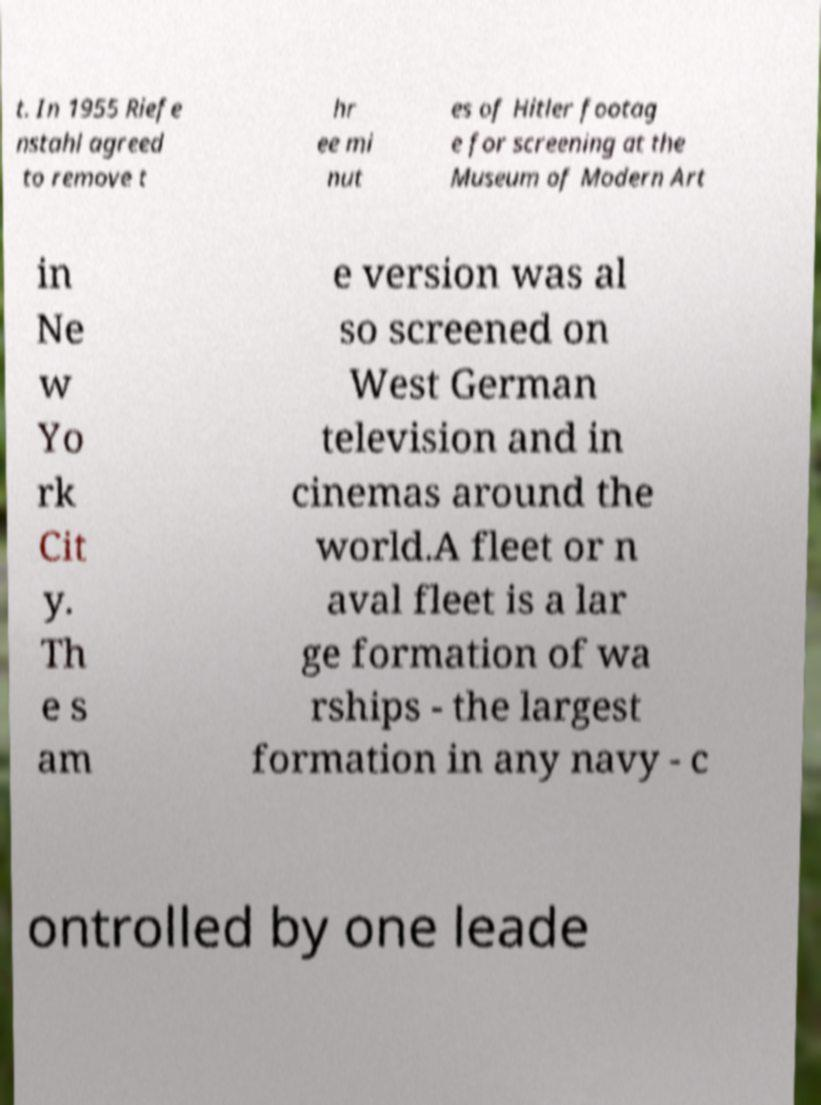Can you accurately transcribe the text from the provided image for me? t. In 1955 Riefe nstahl agreed to remove t hr ee mi nut es of Hitler footag e for screening at the Museum of Modern Art in Ne w Yo rk Cit y. Th e s am e version was al so screened on West German television and in cinemas around the world.A fleet or n aval fleet is a lar ge formation of wa rships - the largest formation in any navy - c ontrolled by one leade 